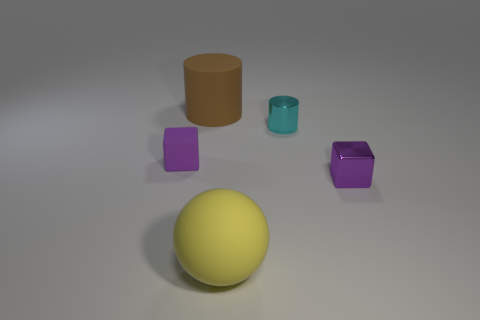There is a small purple object to the right of the tiny purple matte cube; is it the same shape as the purple thing that is left of the cyan cylinder?
Your answer should be compact. Yes. How many other cubes are the same color as the metal block?
Ensure brevity in your answer.  1. Does the block on the right side of the large yellow matte object have the same color as the thing to the left of the big cylinder?
Offer a terse response. Yes. There is a metallic cube that is the same color as the tiny rubber object; what size is it?
Ensure brevity in your answer.  Small. What size is the purple metallic block?
Your response must be concise. Small. What is the shape of the tiny purple rubber thing?
Make the answer very short. Cube. Does the tiny cube that is to the left of the metallic cylinder have the same color as the metallic cube?
Offer a very short reply. Yes. There is another purple thing that is the same shape as the purple metallic thing; what size is it?
Provide a succinct answer. Small. Is there a rubber sphere that is behind the large brown object that is behind the rubber thing right of the large rubber cylinder?
Provide a succinct answer. No. What is the cube in front of the small purple rubber cube made of?
Your answer should be very brief. Metal. 